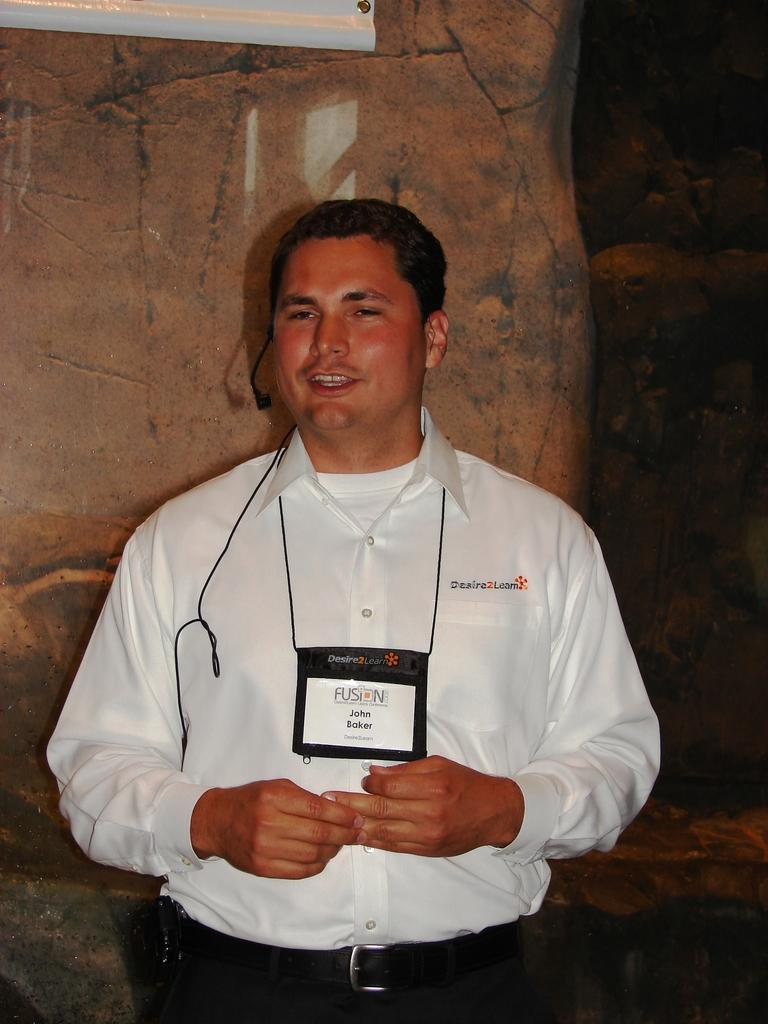Who is present in the image? There is a man in the image. What is attached to the man's neck? The man has a tag on his neck. What type of natural elements can be seen in the background of the image? There are rocks in the background of the image. Can you describe the object at the top of the image? Unfortunately, the facts provided do not give enough information to describe the object at the top of the image. What type of glove is the man wearing in the image? There is no glove mentioned or visible in the image. How many arrows are in the quiver on the man's back in the image? There is no quiver or arrows present in the image. 